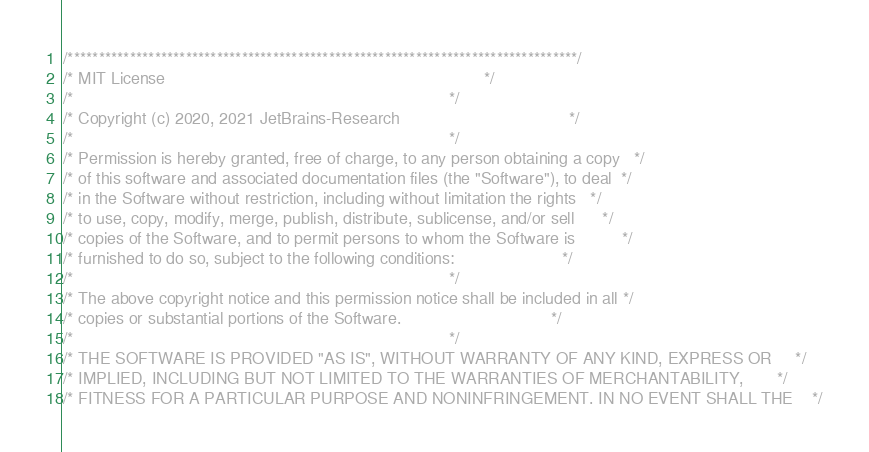<code> <loc_0><loc_0><loc_500><loc_500><_C++_>/**********************************************************************************/
/* MIT License                                                                    */
/*                                                                                */
/* Copyright (c) 2020, 2021 JetBrains-Research                                    */
/*                                                                                */
/* Permission is hereby granted, free of charge, to any person obtaining a copy   */
/* of this software and associated documentation files (the "Software"), to deal  */
/* in the Software without restriction, including without limitation the rights   */
/* to use, copy, modify, merge, publish, distribute, sublicense, and/or sell      */
/* copies of the Software, and to permit persons to whom the Software is          */
/* furnished to do so, subject to the following conditions:                       */
/*                                                                                */
/* The above copyright notice and this permission notice shall be included in all */
/* copies or substantial portions of the Software.                                */
/*                                                                                */
/* THE SOFTWARE IS PROVIDED "AS IS", WITHOUT WARRANTY OF ANY KIND, EXPRESS OR     */
/* IMPLIED, INCLUDING BUT NOT LIMITED TO THE WARRANTIES OF MERCHANTABILITY,       */
/* FITNESS FOR A PARTICULAR PURPOSE AND NONINFRINGEMENT. IN NO EVENT SHALL THE    */</code> 